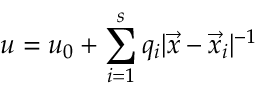Convert formula to latex. <formula><loc_0><loc_0><loc_500><loc_500>u = u _ { 0 } + \sum _ { i = 1 } ^ { s } q _ { i } | \vec { x } - \vec { x } _ { i } | ^ { - 1 }</formula> 